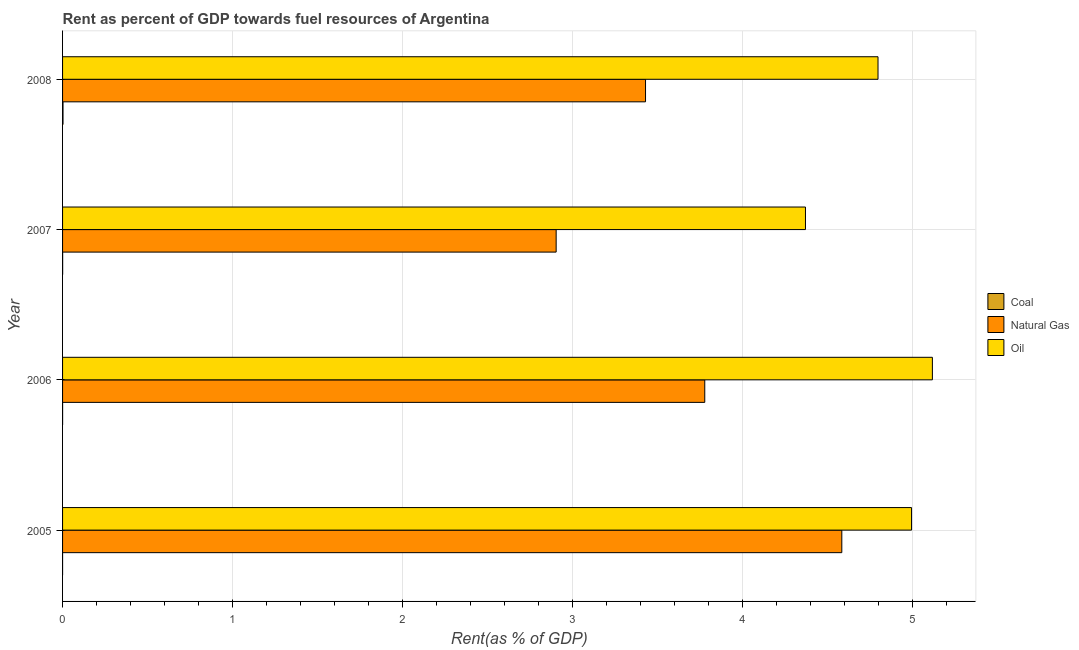How many groups of bars are there?
Offer a very short reply. 4. Are the number of bars per tick equal to the number of legend labels?
Provide a short and direct response. Yes. Are the number of bars on each tick of the Y-axis equal?
Your response must be concise. Yes. How many bars are there on the 3rd tick from the bottom?
Provide a short and direct response. 3. What is the label of the 3rd group of bars from the top?
Provide a succinct answer. 2006. What is the rent towards natural gas in 2007?
Provide a short and direct response. 2.9. Across all years, what is the maximum rent towards oil?
Your answer should be very brief. 5.12. Across all years, what is the minimum rent towards coal?
Your answer should be compact. 2.218481758301961e-5. In which year was the rent towards oil minimum?
Make the answer very short. 2007. What is the total rent towards coal in the graph?
Ensure brevity in your answer.  0. What is the difference between the rent towards natural gas in 2005 and that in 2006?
Your answer should be very brief. 0.81. What is the difference between the rent towards natural gas in 2006 and the rent towards oil in 2007?
Your answer should be compact. -0.59. In the year 2007, what is the difference between the rent towards coal and rent towards oil?
Make the answer very short. -4.37. In how many years, is the rent towards coal greater than 1 %?
Keep it short and to the point. 0. What is the ratio of the rent towards oil in 2005 to that in 2006?
Your response must be concise. 0.98. Is the rent towards oil in 2006 less than that in 2008?
Offer a very short reply. No. Is the difference between the rent towards oil in 2005 and 2006 greater than the difference between the rent towards coal in 2005 and 2006?
Offer a very short reply. No. What is the difference between the highest and the second highest rent towards oil?
Your answer should be very brief. 0.12. What is the difference between the highest and the lowest rent towards natural gas?
Provide a short and direct response. 1.68. In how many years, is the rent towards coal greater than the average rent towards coal taken over all years?
Ensure brevity in your answer.  1. Is the sum of the rent towards oil in 2005 and 2008 greater than the maximum rent towards coal across all years?
Give a very brief answer. Yes. What does the 3rd bar from the top in 2008 represents?
Provide a short and direct response. Coal. What does the 3rd bar from the bottom in 2006 represents?
Offer a terse response. Oil. Is it the case that in every year, the sum of the rent towards coal and rent towards natural gas is greater than the rent towards oil?
Your answer should be very brief. No. Are all the bars in the graph horizontal?
Ensure brevity in your answer.  Yes. How many years are there in the graph?
Provide a short and direct response. 4. Does the graph contain any zero values?
Offer a terse response. No. Does the graph contain grids?
Offer a very short reply. Yes. What is the title of the graph?
Give a very brief answer. Rent as percent of GDP towards fuel resources of Argentina. Does "Total employers" appear as one of the legend labels in the graph?
Keep it short and to the point. No. What is the label or title of the X-axis?
Offer a very short reply. Rent(as % of GDP). What is the label or title of the Y-axis?
Offer a very short reply. Year. What is the Rent(as % of GDP) of Coal in 2005?
Your answer should be very brief. 2.218481758301961e-5. What is the Rent(as % of GDP) in Natural Gas in 2005?
Make the answer very short. 4.58. What is the Rent(as % of GDP) in Oil in 2005?
Make the answer very short. 4.99. What is the Rent(as % of GDP) in Coal in 2006?
Your response must be concise. 0. What is the Rent(as % of GDP) in Natural Gas in 2006?
Offer a very short reply. 3.78. What is the Rent(as % of GDP) of Oil in 2006?
Offer a terse response. 5.12. What is the Rent(as % of GDP) in Coal in 2007?
Your answer should be very brief. 0. What is the Rent(as % of GDP) of Natural Gas in 2007?
Your response must be concise. 2.9. What is the Rent(as % of GDP) in Oil in 2007?
Keep it short and to the point. 4.37. What is the Rent(as % of GDP) in Coal in 2008?
Provide a succinct answer. 0. What is the Rent(as % of GDP) in Natural Gas in 2008?
Your response must be concise. 3.43. What is the Rent(as % of GDP) in Oil in 2008?
Provide a succinct answer. 4.8. Across all years, what is the maximum Rent(as % of GDP) of Coal?
Your answer should be very brief. 0. Across all years, what is the maximum Rent(as % of GDP) in Natural Gas?
Your answer should be very brief. 4.58. Across all years, what is the maximum Rent(as % of GDP) in Oil?
Your response must be concise. 5.12. Across all years, what is the minimum Rent(as % of GDP) of Coal?
Offer a very short reply. 2.218481758301961e-5. Across all years, what is the minimum Rent(as % of GDP) in Natural Gas?
Ensure brevity in your answer.  2.9. Across all years, what is the minimum Rent(as % of GDP) in Oil?
Provide a succinct answer. 4.37. What is the total Rent(as % of GDP) of Coal in the graph?
Your response must be concise. 0. What is the total Rent(as % of GDP) of Natural Gas in the graph?
Offer a very short reply. 14.69. What is the total Rent(as % of GDP) of Oil in the graph?
Your answer should be very brief. 19.28. What is the difference between the Rent(as % of GDP) in Coal in 2005 and that in 2006?
Make the answer very short. -0. What is the difference between the Rent(as % of GDP) of Natural Gas in 2005 and that in 2006?
Keep it short and to the point. 0.81. What is the difference between the Rent(as % of GDP) of Oil in 2005 and that in 2006?
Make the answer very short. -0.12. What is the difference between the Rent(as % of GDP) of Coal in 2005 and that in 2007?
Provide a short and direct response. -0. What is the difference between the Rent(as % of GDP) of Natural Gas in 2005 and that in 2007?
Your answer should be very brief. 1.68. What is the difference between the Rent(as % of GDP) of Oil in 2005 and that in 2007?
Your response must be concise. 0.62. What is the difference between the Rent(as % of GDP) of Coal in 2005 and that in 2008?
Keep it short and to the point. -0. What is the difference between the Rent(as % of GDP) of Natural Gas in 2005 and that in 2008?
Your answer should be compact. 1.15. What is the difference between the Rent(as % of GDP) in Oil in 2005 and that in 2008?
Your answer should be compact. 0.2. What is the difference between the Rent(as % of GDP) of Coal in 2006 and that in 2007?
Your response must be concise. -0. What is the difference between the Rent(as % of GDP) in Natural Gas in 2006 and that in 2007?
Your answer should be very brief. 0.87. What is the difference between the Rent(as % of GDP) of Oil in 2006 and that in 2007?
Your response must be concise. 0.75. What is the difference between the Rent(as % of GDP) of Coal in 2006 and that in 2008?
Offer a terse response. -0. What is the difference between the Rent(as % of GDP) of Natural Gas in 2006 and that in 2008?
Your answer should be very brief. 0.35. What is the difference between the Rent(as % of GDP) of Oil in 2006 and that in 2008?
Your response must be concise. 0.32. What is the difference between the Rent(as % of GDP) of Coal in 2007 and that in 2008?
Your response must be concise. -0. What is the difference between the Rent(as % of GDP) in Natural Gas in 2007 and that in 2008?
Give a very brief answer. -0.53. What is the difference between the Rent(as % of GDP) of Oil in 2007 and that in 2008?
Your answer should be compact. -0.43. What is the difference between the Rent(as % of GDP) of Coal in 2005 and the Rent(as % of GDP) of Natural Gas in 2006?
Offer a terse response. -3.78. What is the difference between the Rent(as % of GDP) of Coal in 2005 and the Rent(as % of GDP) of Oil in 2006?
Give a very brief answer. -5.12. What is the difference between the Rent(as % of GDP) in Natural Gas in 2005 and the Rent(as % of GDP) in Oil in 2006?
Ensure brevity in your answer.  -0.53. What is the difference between the Rent(as % of GDP) of Coal in 2005 and the Rent(as % of GDP) of Natural Gas in 2007?
Ensure brevity in your answer.  -2.9. What is the difference between the Rent(as % of GDP) in Coal in 2005 and the Rent(as % of GDP) in Oil in 2007?
Offer a very short reply. -4.37. What is the difference between the Rent(as % of GDP) in Natural Gas in 2005 and the Rent(as % of GDP) in Oil in 2007?
Offer a terse response. 0.21. What is the difference between the Rent(as % of GDP) in Coal in 2005 and the Rent(as % of GDP) in Natural Gas in 2008?
Your answer should be compact. -3.43. What is the difference between the Rent(as % of GDP) in Coal in 2005 and the Rent(as % of GDP) in Oil in 2008?
Ensure brevity in your answer.  -4.8. What is the difference between the Rent(as % of GDP) of Natural Gas in 2005 and the Rent(as % of GDP) of Oil in 2008?
Your response must be concise. -0.21. What is the difference between the Rent(as % of GDP) of Coal in 2006 and the Rent(as % of GDP) of Natural Gas in 2007?
Ensure brevity in your answer.  -2.9. What is the difference between the Rent(as % of GDP) of Coal in 2006 and the Rent(as % of GDP) of Oil in 2007?
Provide a short and direct response. -4.37. What is the difference between the Rent(as % of GDP) of Natural Gas in 2006 and the Rent(as % of GDP) of Oil in 2007?
Your answer should be very brief. -0.59. What is the difference between the Rent(as % of GDP) of Coal in 2006 and the Rent(as % of GDP) of Natural Gas in 2008?
Keep it short and to the point. -3.43. What is the difference between the Rent(as % of GDP) of Coal in 2006 and the Rent(as % of GDP) of Oil in 2008?
Ensure brevity in your answer.  -4.8. What is the difference between the Rent(as % of GDP) in Natural Gas in 2006 and the Rent(as % of GDP) in Oil in 2008?
Give a very brief answer. -1.02. What is the difference between the Rent(as % of GDP) of Coal in 2007 and the Rent(as % of GDP) of Natural Gas in 2008?
Offer a very short reply. -3.43. What is the difference between the Rent(as % of GDP) in Coal in 2007 and the Rent(as % of GDP) in Oil in 2008?
Provide a succinct answer. -4.8. What is the difference between the Rent(as % of GDP) in Natural Gas in 2007 and the Rent(as % of GDP) in Oil in 2008?
Provide a short and direct response. -1.89. What is the average Rent(as % of GDP) of Coal per year?
Your answer should be very brief. 0. What is the average Rent(as % of GDP) of Natural Gas per year?
Give a very brief answer. 3.67. What is the average Rent(as % of GDP) of Oil per year?
Give a very brief answer. 4.82. In the year 2005, what is the difference between the Rent(as % of GDP) in Coal and Rent(as % of GDP) in Natural Gas?
Ensure brevity in your answer.  -4.58. In the year 2005, what is the difference between the Rent(as % of GDP) in Coal and Rent(as % of GDP) in Oil?
Keep it short and to the point. -4.99. In the year 2005, what is the difference between the Rent(as % of GDP) in Natural Gas and Rent(as % of GDP) in Oil?
Your answer should be very brief. -0.41. In the year 2006, what is the difference between the Rent(as % of GDP) in Coal and Rent(as % of GDP) in Natural Gas?
Offer a very short reply. -3.78. In the year 2006, what is the difference between the Rent(as % of GDP) of Coal and Rent(as % of GDP) of Oil?
Offer a very short reply. -5.12. In the year 2006, what is the difference between the Rent(as % of GDP) of Natural Gas and Rent(as % of GDP) of Oil?
Your answer should be very brief. -1.34. In the year 2007, what is the difference between the Rent(as % of GDP) of Coal and Rent(as % of GDP) of Natural Gas?
Your answer should be very brief. -2.9. In the year 2007, what is the difference between the Rent(as % of GDP) in Coal and Rent(as % of GDP) in Oil?
Your response must be concise. -4.37. In the year 2007, what is the difference between the Rent(as % of GDP) of Natural Gas and Rent(as % of GDP) of Oil?
Your response must be concise. -1.47. In the year 2008, what is the difference between the Rent(as % of GDP) of Coal and Rent(as % of GDP) of Natural Gas?
Keep it short and to the point. -3.43. In the year 2008, what is the difference between the Rent(as % of GDP) of Coal and Rent(as % of GDP) of Oil?
Provide a succinct answer. -4.79. In the year 2008, what is the difference between the Rent(as % of GDP) in Natural Gas and Rent(as % of GDP) in Oil?
Offer a terse response. -1.37. What is the ratio of the Rent(as % of GDP) of Coal in 2005 to that in 2006?
Provide a succinct answer. 0.11. What is the ratio of the Rent(as % of GDP) in Natural Gas in 2005 to that in 2006?
Offer a terse response. 1.21. What is the ratio of the Rent(as % of GDP) in Oil in 2005 to that in 2006?
Your answer should be very brief. 0.98. What is the ratio of the Rent(as % of GDP) of Coal in 2005 to that in 2007?
Make the answer very short. 0.05. What is the ratio of the Rent(as % of GDP) in Natural Gas in 2005 to that in 2007?
Keep it short and to the point. 1.58. What is the ratio of the Rent(as % of GDP) of Oil in 2005 to that in 2007?
Give a very brief answer. 1.14. What is the ratio of the Rent(as % of GDP) in Coal in 2005 to that in 2008?
Ensure brevity in your answer.  0.01. What is the ratio of the Rent(as % of GDP) in Natural Gas in 2005 to that in 2008?
Keep it short and to the point. 1.34. What is the ratio of the Rent(as % of GDP) in Oil in 2005 to that in 2008?
Make the answer very short. 1.04. What is the ratio of the Rent(as % of GDP) of Coal in 2006 to that in 2007?
Ensure brevity in your answer.  0.43. What is the ratio of the Rent(as % of GDP) of Natural Gas in 2006 to that in 2007?
Give a very brief answer. 1.3. What is the ratio of the Rent(as % of GDP) in Oil in 2006 to that in 2007?
Your response must be concise. 1.17. What is the ratio of the Rent(as % of GDP) in Coal in 2006 to that in 2008?
Give a very brief answer. 0.07. What is the ratio of the Rent(as % of GDP) of Natural Gas in 2006 to that in 2008?
Make the answer very short. 1.1. What is the ratio of the Rent(as % of GDP) of Oil in 2006 to that in 2008?
Provide a succinct answer. 1.07. What is the ratio of the Rent(as % of GDP) of Coal in 2007 to that in 2008?
Provide a succinct answer. 0.17. What is the ratio of the Rent(as % of GDP) in Natural Gas in 2007 to that in 2008?
Ensure brevity in your answer.  0.85. What is the ratio of the Rent(as % of GDP) in Oil in 2007 to that in 2008?
Ensure brevity in your answer.  0.91. What is the difference between the highest and the second highest Rent(as % of GDP) of Coal?
Offer a very short reply. 0. What is the difference between the highest and the second highest Rent(as % of GDP) in Natural Gas?
Your answer should be very brief. 0.81. What is the difference between the highest and the second highest Rent(as % of GDP) in Oil?
Keep it short and to the point. 0.12. What is the difference between the highest and the lowest Rent(as % of GDP) in Coal?
Ensure brevity in your answer.  0. What is the difference between the highest and the lowest Rent(as % of GDP) in Natural Gas?
Ensure brevity in your answer.  1.68. What is the difference between the highest and the lowest Rent(as % of GDP) of Oil?
Ensure brevity in your answer.  0.75. 